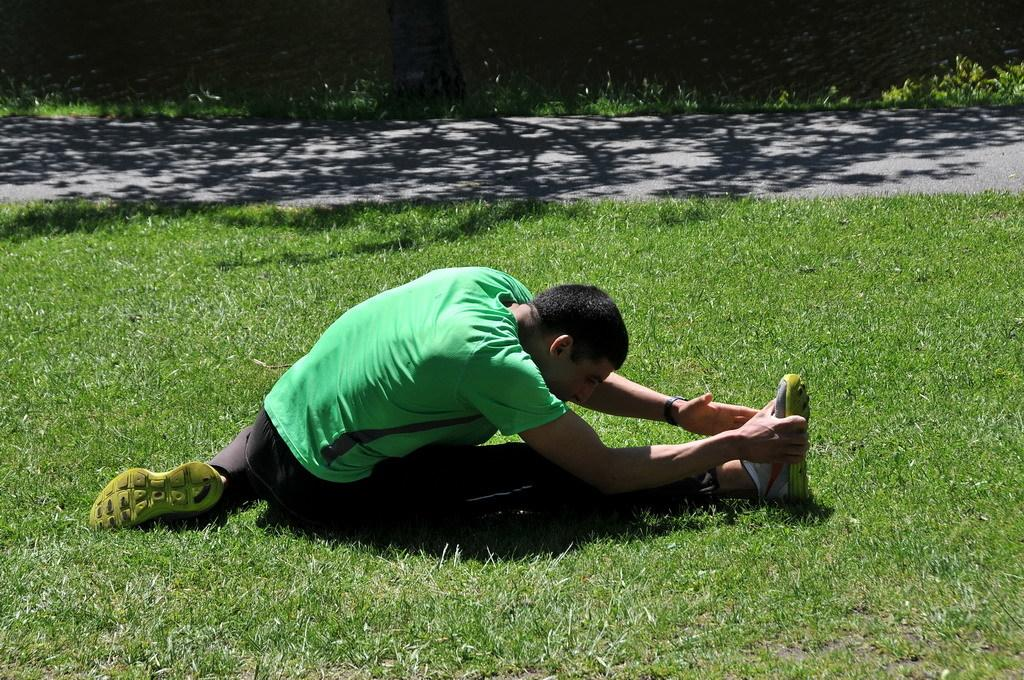Who is present in the image? There is a man in the image. What is the man wearing? The man is wearing a green T-shirt and black pants. What activity is the man engaged in? The man is doing yoga. Where does the scene take place? The scene takes place in a garden. What can be seen in the background of the image? There is a road visible in the background of the image. What historical event is taking place in the image? There is no historical event taking place in the image; it depicts a man doing yoga in a garden. Is it raining in the image? There is no indication of rain in the image; the sky is not visible, and the man is doing yoga outdoors in a garden. 